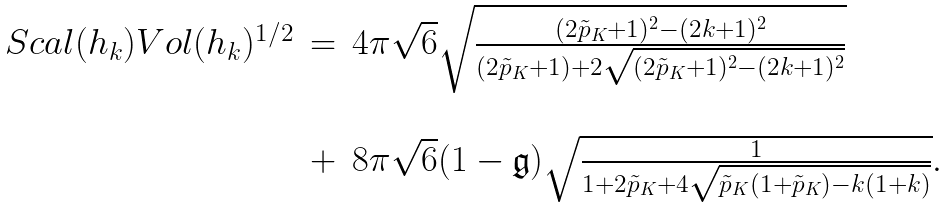<formula> <loc_0><loc_0><loc_500><loc_500>\begin{array} { c c l } S c a l ( h _ { k } ) V o l ( h _ { k } ) ^ { 1 / 2 } & = & 4 \pi \sqrt { 6 } \sqrt { \frac { ( 2 \tilde { p } _ { K } + 1 ) ^ { 2 } - ( 2 k + 1 ) ^ { 2 } } { ( 2 \tilde { p } _ { K } + 1 ) + 2 \sqrt { ( 2 \tilde { p } _ { K } + 1 ) ^ { 2 } - ( 2 k + 1 ) ^ { 2 } } } } \\ \\ & + & 8 \pi \sqrt { 6 } ( 1 - \mathfrak { g } ) \sqrt { \frac { 1 } { 1 + 2 \tilde { p } _ { K } + 4 \sqrt { \tilde { p } _ { K } ( 1 + \tilde { p } _ { K } ) - k ( 1 + k ) } } } . \end{array}</formula> 